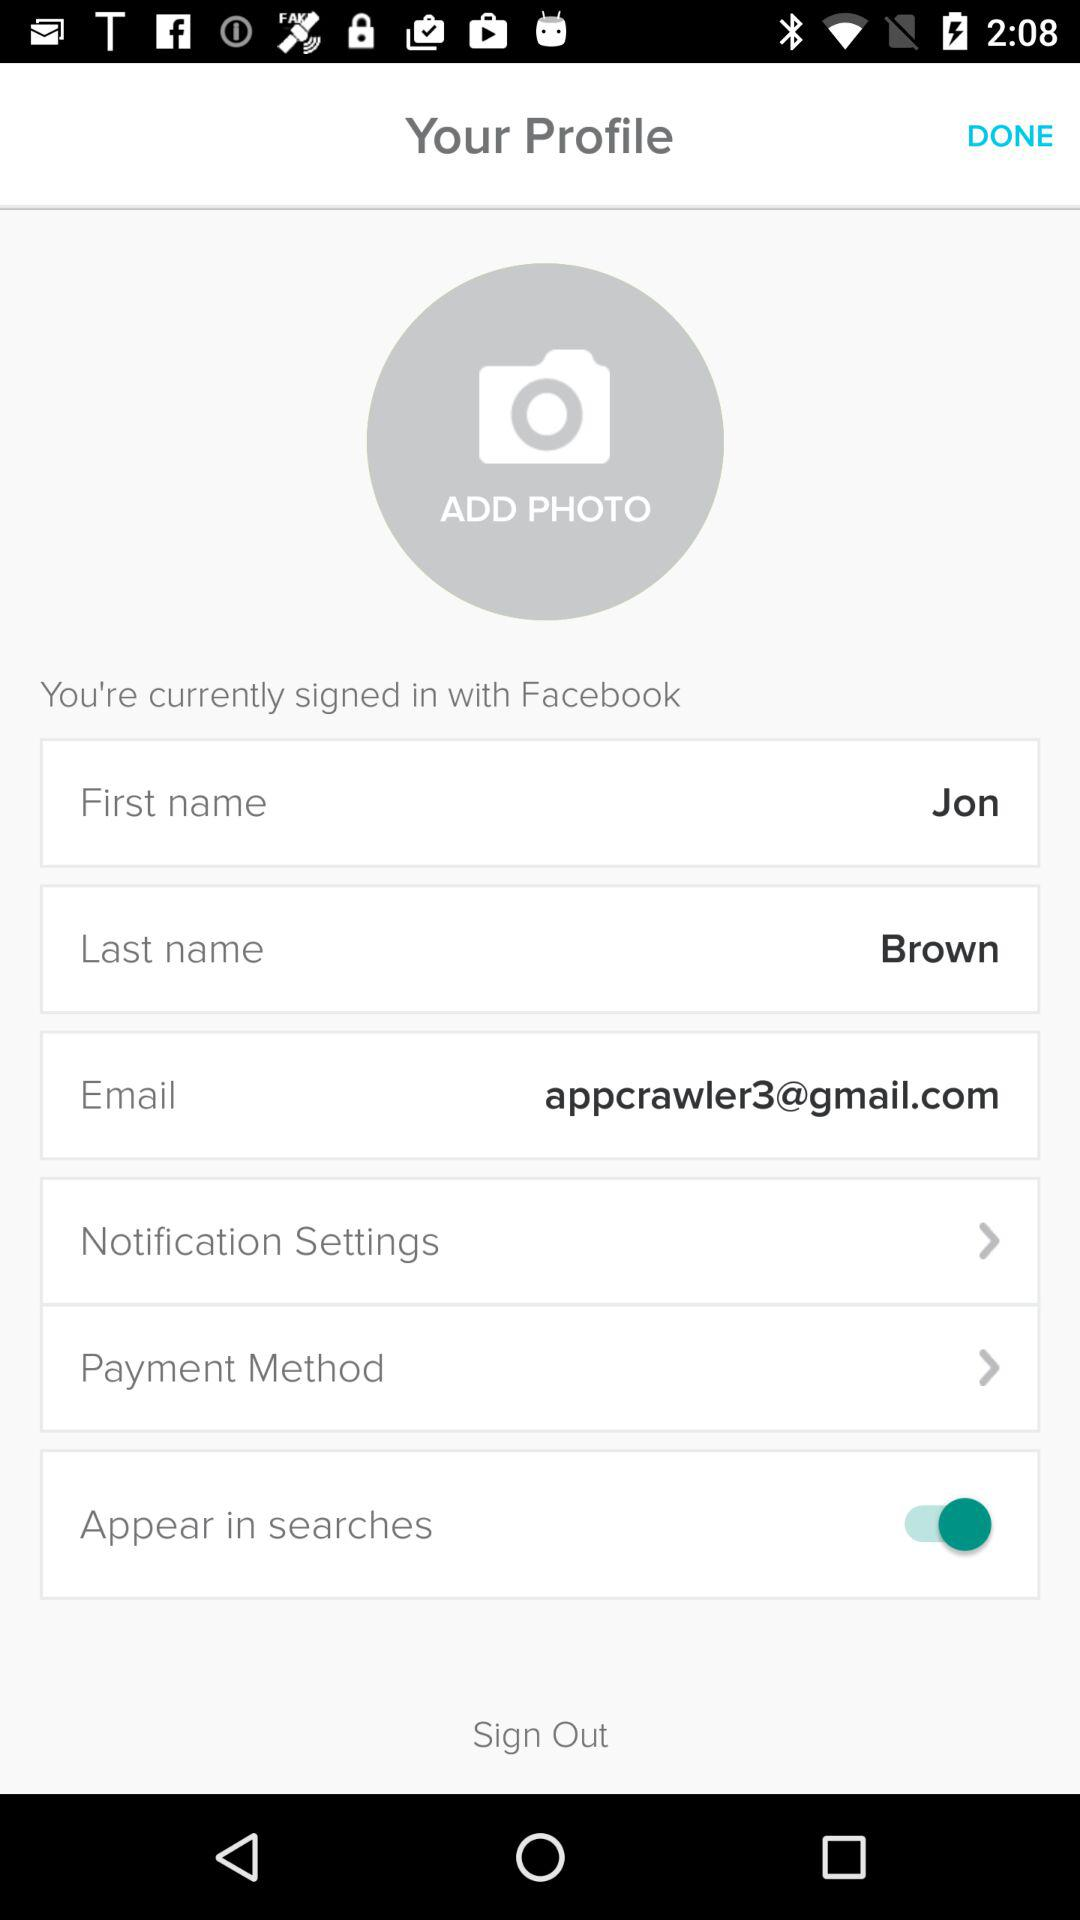Is "Appear in searches" enabled or disabled? "Appear in searches" is "enabled". 